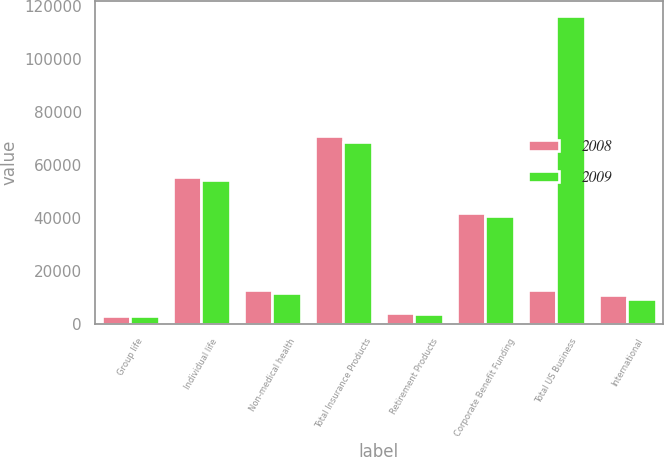<chart> <loc_0><loc_0><loc_500><loc_500><stacked_bar_chart><ecel><fcel>Group life<fcel>Individual life<fcel>Non-medical health<fcel>Total Insurance Products<fcel>Retirement Products<fcel>Corporate Benefit Funding<fcel>Total US Business<fcel>International<nl><fcel>2008<fcel>2981<fcel>55302<fcel>12738<fcel>71021<fcel>3978<fcel>41614<fcel>12738<fcel>10830<nl><fcel>2009<fcel>2984<fcel>54099<fcel>11619<fcel>68702<fcel>3655<fcel>40682<fcel>116122<fcel>9241<nl></chart> 